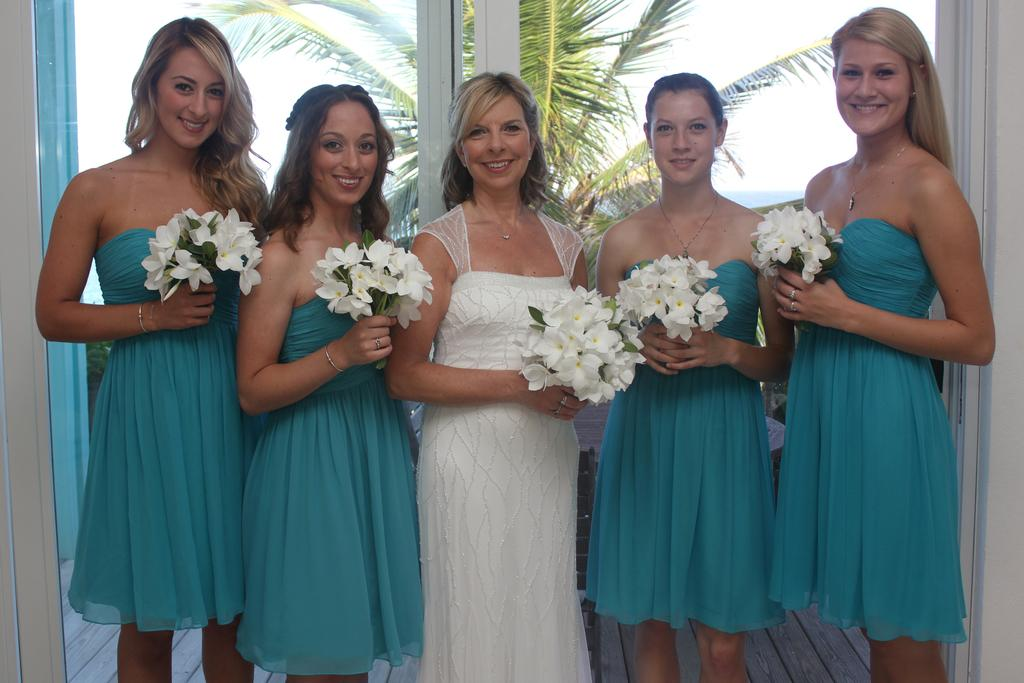How many women are present in the image? There are five women in the image. What expressions do the women have on their faces? The women are smiling in the image. What are the women holding in their hands? The women are holding flowers in their hands. What can be seen in the background of the image? There is a glass door, trees, and the sky visible in the background of the image. What type of vacation destination is depicted in the image? There is no indication of a vacation destination in the image; it simply shows five women holding flowers and smiling. 